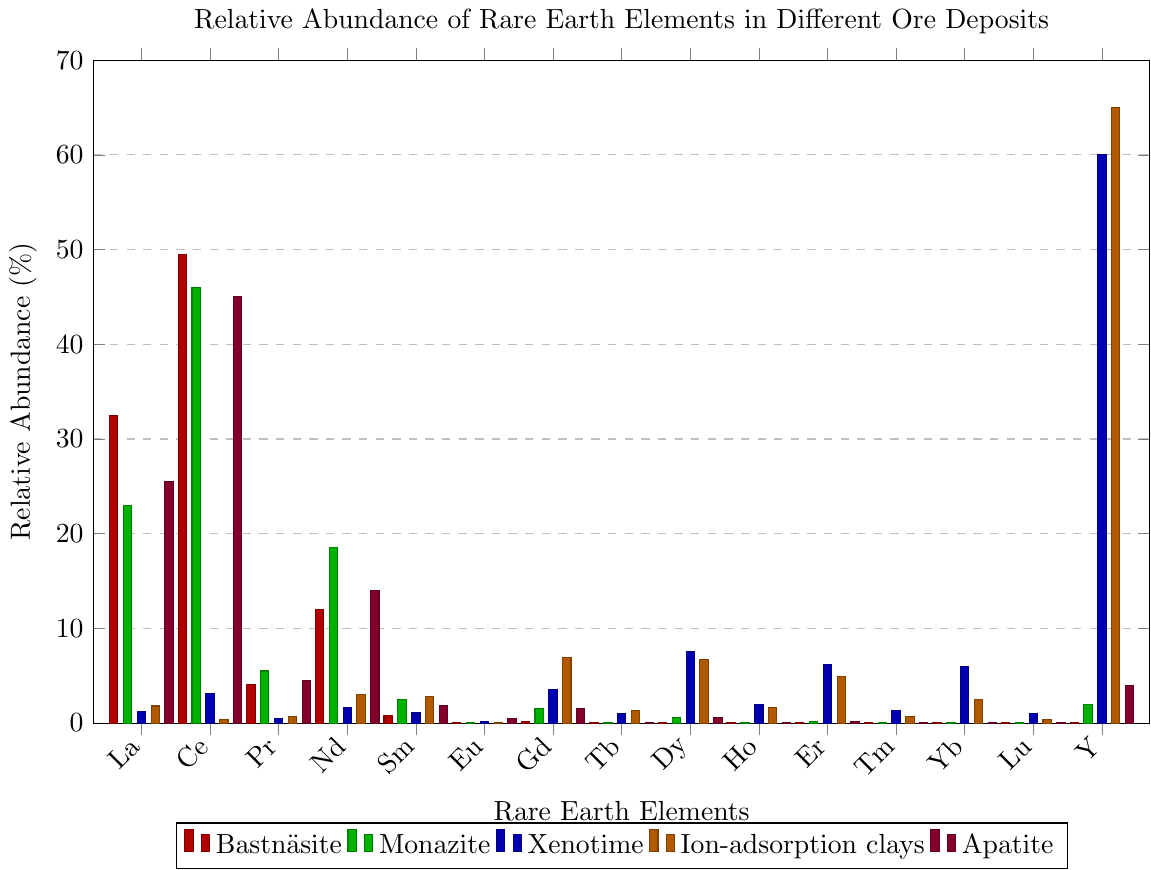Which element has the highest relative abundance in Bastnäsite? Examine the bars corresponding to Bastnäsite for each element and identify the tallest bar. The tallest bar is at Cerium (Ce) with a height of 49.5.
Answer: Cerium Which ore deposit has the highest relative abundance of Yttrium (Y)? Look at the heights of the bars representing Yttrium (Y) across all ore deposits and find the tallest one, which is exhibited by Ion-adsorption clays at a height of 65.0.
Answer: Ion-adsorption clays Among Neodymium (Nd) and Dysprosium (Dy) in Apatite, which element is more abundant? Compare the heights of the bars representing Neodymium (Nd) and Dysprosium (Dy) in the Apatite series. Neodymium has a height of 14.0, while Dysprosium has a height of 0.6.
Answer: Neodymium Calculate the average relative abundance of Lanthanum (La) across all ore deposits. Sum the relative abundances of Lanthanum for all deposits (32.5 + 23.0 + 1.2 + 1.8 + 25.5 = 84.0) and divide by the number of deposits (5). 84.0 / 5 = 16.8.
Answer: 16.8 Which ore deposit has the lowest total relative abundance of Europium (Eu), Terbium (Tb), and Holmium (Ho)? For each deposit, sum the relative abundances of Europium, Terbium, and Holmium, then compare the totals.
- Bastnäsite: 0.1 + 0.01 + 0.01 = 0.12
- Monazite: 0.1 + 0.1 + 0.1 = 0.3
- Xenotime: 0.2 + 1.0 + 2.0 = 3.2
- Ion-adsorption clays: 0.1 + 1.3 + 1.6 = 3.0
- Apatite: 0.5 + 0.1 + 0.1 = 0.7
The lowest total is for Bastnäsite with 0.12.
Answer: Bastnäsite Of the ore deposits shown, which one has the most balanced relative abundance of rare earth elements? To find which deposit has the most balanced distribution, visually assess the uniformity of bar heights across different elements. Monazite and Bastnäsite seem more balanced compared to others where certain elements have significantly higher values.
Answer: Monazite / Bastnäsite What is the difference in relative abundance of Gadolinium (Gd) between Ion-adsorption clays and Xenotime? Compare the bar heights for Gadolinium (Gd) in Ion-adsorption clays and Xenotime. For Ion-adsorption clays: 6.9; for Xenotime: 3.5. Difference is 6.9 - 3.5 = 3.4.
Answer: 3.4 What is the median relative abundance of elements in Monazite? First, list the relative abundances in Monazite and sort them: [0.01, 0.01, 0.1, 0.1, 0.1, 0.2, 0.6, 1.5, 2.0, 2.5, 5.5, 18.5, 23.0, 46.0]. The median is the middle value when sorted, which is the 7th and 8th values averaged: (0.6 + 1.5) / 2 = 1.05.
Answer: 1.05 Is there any element with more than 50% relative abundance in any ore deposit? Check the heights of bars for all elements across deposits to see if any exceeds 50%. Yttrium (Y) in both Xenotime and Ion-adsorption clays exceed 50% (60.0 and 65.0 respectively).
Answer: Yes Between Apatite and Bastnäsite, which has a higher relative abundance of Cerium (Ce)? Compare the heights of bars representing Cerium (Ce) in Apatite and Bastnäsite. Apatite has 45.0 while Bastnäsite has 49.5.
Answer: Bastnäsite 